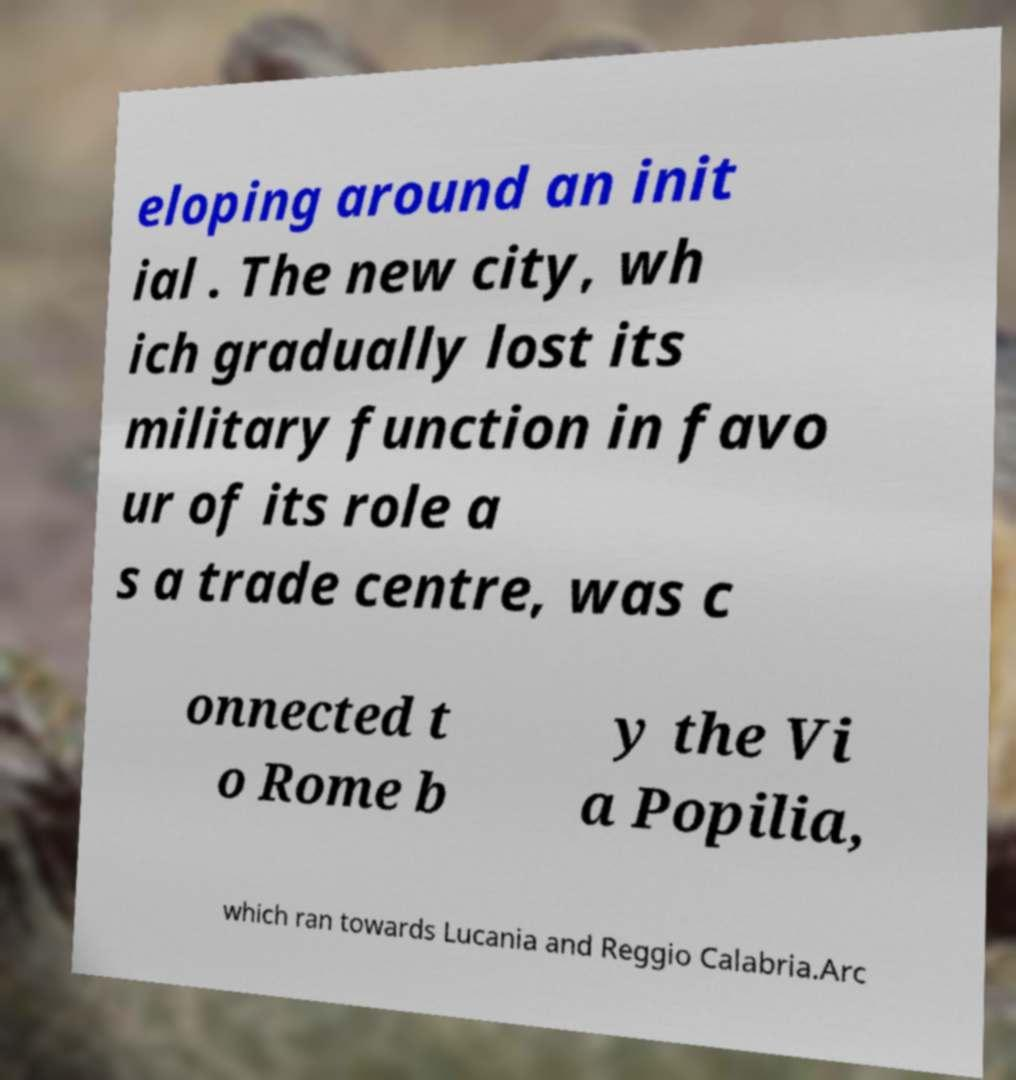Can you read and provide the text displayed in the image?This photo seems to have some interesting text. Can you extract and type it out for me? eloping around an init ial . The new city, wh ich gradually lost its military function in favo ur of its role a s a trade centre, was c onnected t o Rome b y the Vi a Popilia, which ran towards Lucania and Reggio Calabria.Arc 